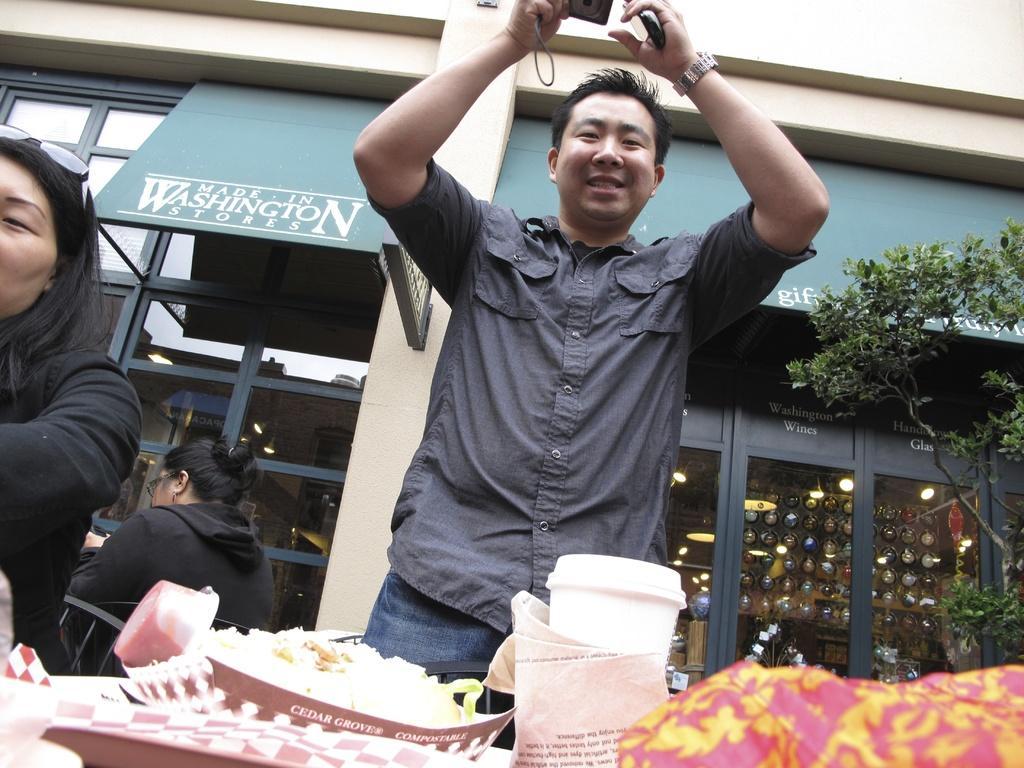Could you give a brief overview of what you see in this image? This image is taken outdoors. In the background there is a building with walls and doors. There is a board with a text on it. There are a few boards with text on them. There are a few lights. On the right side of the image there is a tree. At the bottom of the image there is a table with a tray, a tumbler, tissue papers, a box with food item and a few things on it. In the middle of the image a man is standing and he is holding a camera and a mobile phone in his hands. On the left side of the image to women are sitting on the chairs. 